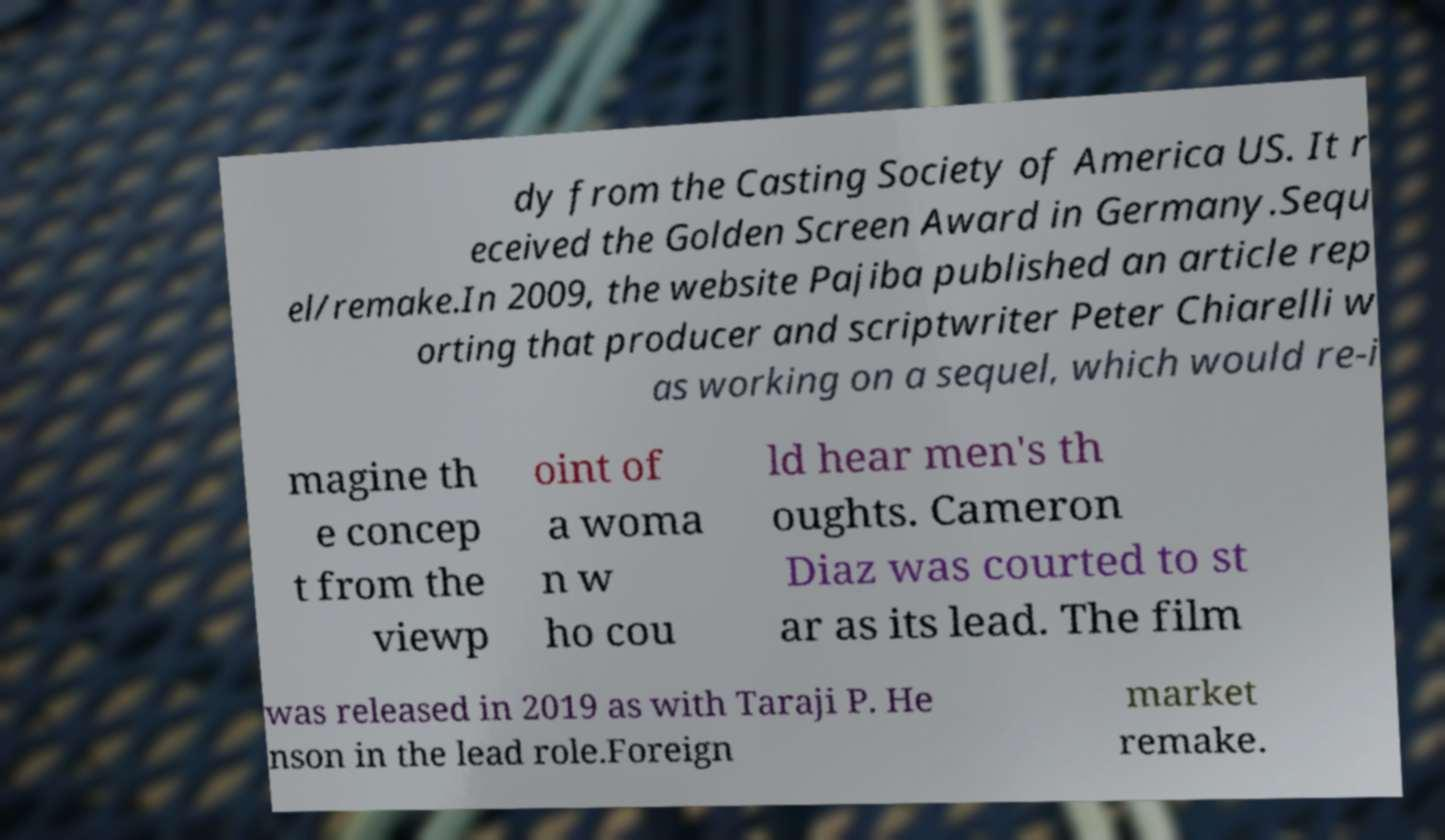For documentation purposes, I need the text within this image transcribed. Could you provide that? dy from the Casting Society of America US. It r eceived the Golden Screen Award in Germany.Sequ el/remake.In 2009, the website Pajiba published an article rep orting that producer and scriptwriter Peter Chiarelli w as working on a sequel, which would re-i magine th e concep t from the viewp oint of a woma n w ho cou ld hear men's th oughts. Cameron Diaz was courted to st ar as its lead. The film was released in 2019 as with Taraji P. He nson in the lead role.Foreign market remake. 